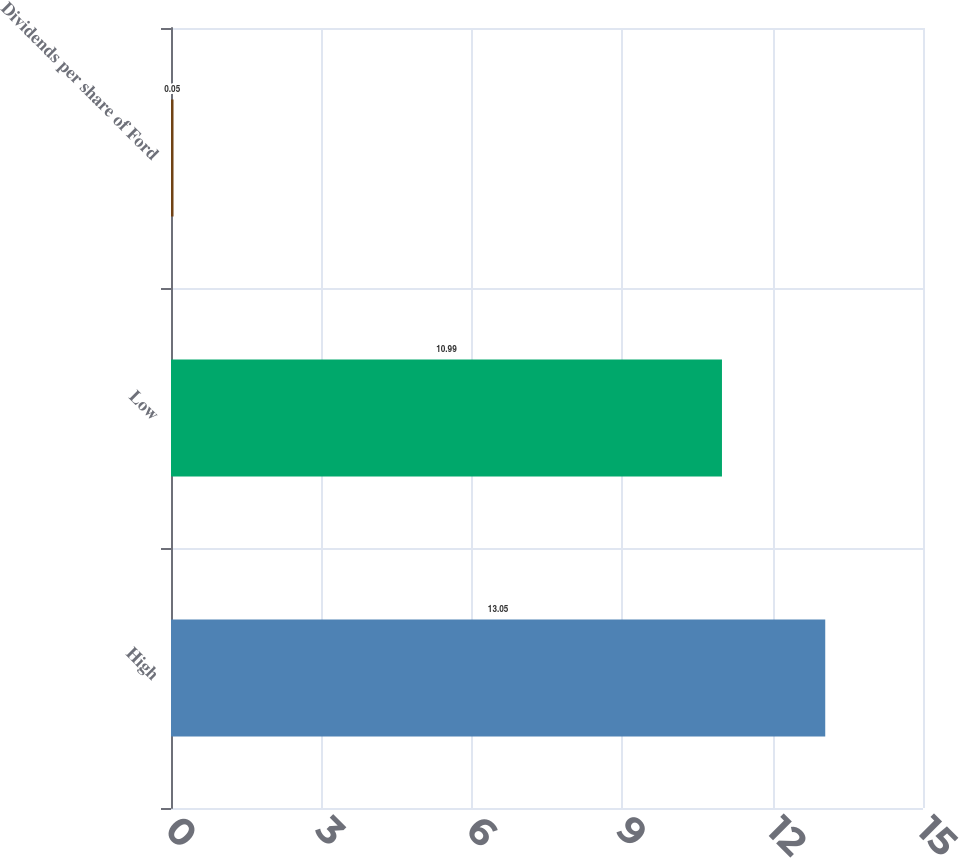<chart> <loc_0><loc_0><loc_500><loc_500><bar_chart><fcel>High<fcel>Low<fcel>Dividends per share of Ford<nl><fcel>13.05<fcel>10.99<fcel>0.05<nl></chart> 